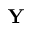Convert formula to latex. <formula><loc_0><loc_0><loc_500><loc_500>Y</formula> 